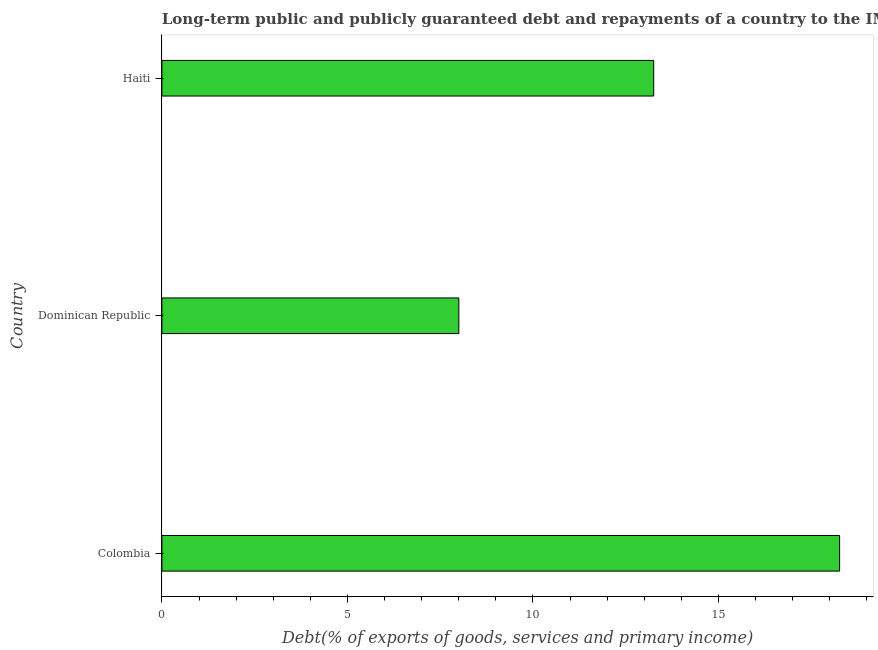Does the graph contain grids?
Your answer should be very brief. No. What is the title of the graph?
Your response must be concise. Long-term public and publicly guaranteed debt and repayments of a country to the IMF in 1971. What is the label or title of the X-axis?
Provide a short and direct response. Debt(% of exports of goods, services and primary income). What is the debt service in Haiti?
Offer a terse response. 13.25. Across all countries, what is the maximum debt service?
Keep it short and to the point. 18.26. Across all countries, what is the minimum debt service?
Give a very brief answer. 8. In which country was the debt service maximum?
Provide a succinct answer. Colombia. In which country was the debt service minimum?
Give a very brief answer. Dominican Republic. What is the sum of the debt service?
Offer a very short reply. 39.52. What is the difference between the debt service in Colombia and Dominican Republic?
Offer a terse response. 10.26. What is the average debt service per country?
Your answer should be very brief. 13.17. What is the median debt service?
Your answer should be very brief. 13.25. In how many countries, is the debt service greater than 3 %?
Your answer should be very brief. 3. What is the ratio of the debt service in Colombia to that in Haiti?
Your answer should be very brief. 1.38. Is the debt service in Colombia less than that in Dominican Republic?
Your answer should be compact. No. What is the difference between the highest and the second highest debt service?
Your response must be concise. 5.01. What is the difference between the highest and the lowest debt service?
Your answer should be compact. 10.26. In how many countries, is the debt service greater than the average debt service taken over all countries?
Provide a short and direct response. 2. Are all the bars in the graph horizontal?
Provide a succinct answer. Yes. Are the values on the major ticks of X-axis written in scientific E-notation?
Your answer should be compact. No. What is the Debt(% of exports of goods, services and primary income) of Colombia?
Your answer should be very brief. 18.26. What is the Debt(% of exports of goods, services and primary income) of Dominican Republic?
Offer a very short reply. 8. What is the Debt(% of exports of goods, services and primary income) of Haiti?
Your answer should be very brief. 13.25. What is the difference between the Debt(% of exports of goods, services and primary income) in Colombia and Dominican Republic?
Make the answer very short. 10.26. What is the difference between the Debt(% of exports of goods, services and primary income) in Colombia and Haiti?
Your response must be concise. 5.01. What is the difference between the Debt(% of exports of goods, services and primary income) in Dominican Republic and Haiti?
Offer a terse response. -5.25. What is the ratio of the Debt(% of exports of goods, services and primary income) in Colombia to that in Dominican Republic?
Provide a short and direct response. 2.28. What is the ratio of the Debt(% of exports of goods, services and primary income) in Colombia to that in Haiti?
Provide a succinct answer. 1.38. What is the ratio of the Debt(% of exports of goods, services and primary income) in Dominican Republic to that in Haiti?
Offer a very short reply. 0.6. 